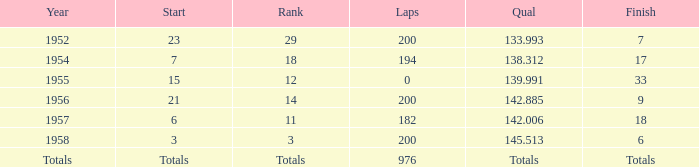What place did Jimmy Reece finish in 1957? 18.0. 